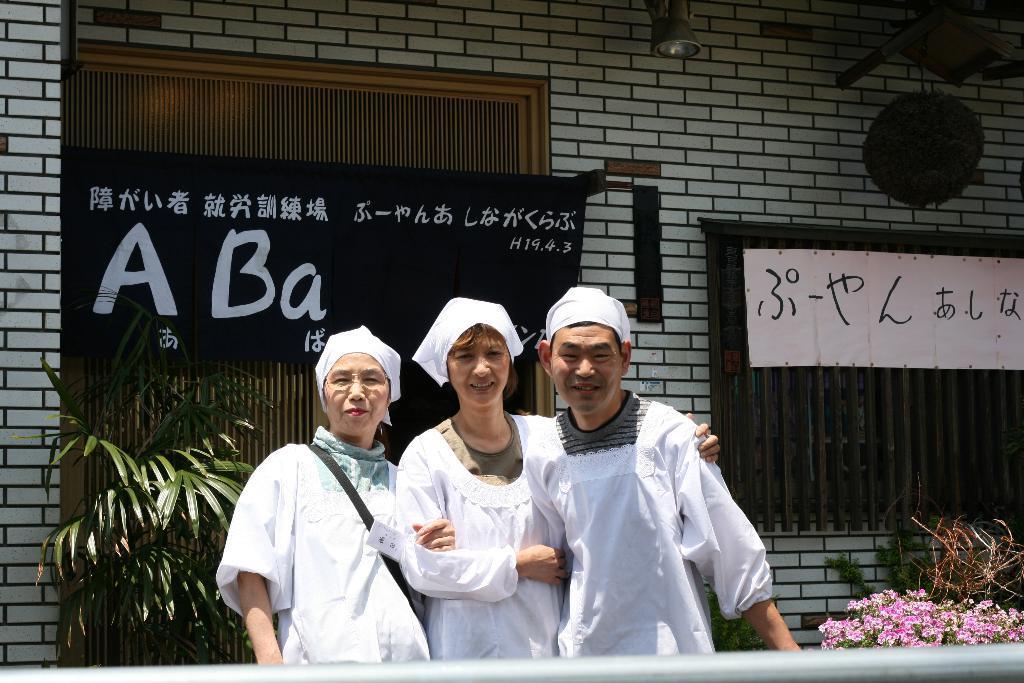In one or two sentences, can you explain what this image depicts? In this picture, we see a two women and a man are standing. They are smiling and they are posing for the photo. Beside them, we see a plant which has the pink flowers. Behind them, we see a plant pot and a banner in black color with some text written on it. On the right side, we see a white wall and a board in white color with some text written on it. In the background, we see a wall, light and a window blind. 